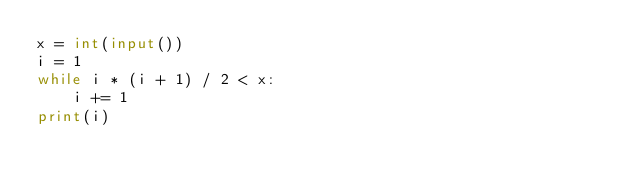<code> <loc_0><loc_0><loc_500><loc_500><_Python_>x = int(input())
i = 1
while i * (i + 1) / 2 < x:
	i += 1
print(i)</code> 